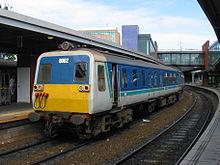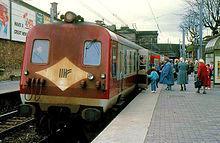The first image is the image on the left, the second image is the image on the right. Analyze the images presented: Is the assertion "There are two trains in total traveling in the same direction." valid? Answer yes or no. Yes. The first image is the image on the left, the second image is the image on the right. Examine the images to the left and right. Is the description "In total, the images contain two trains featuring blue and yellow coloring." accurate? Answer yes or no. No. 